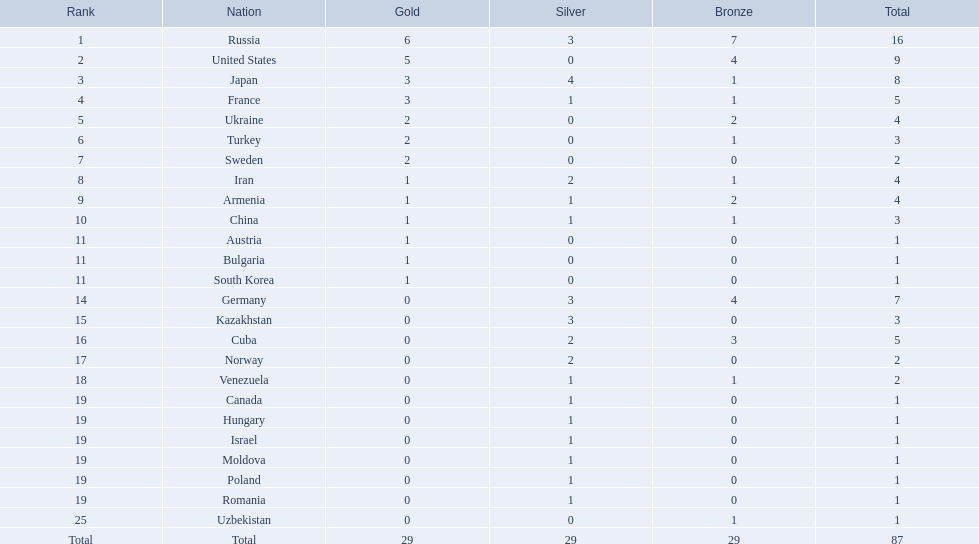What were the nations that participated in the 1995 world wrestling championships? Russia, United States, Japan, France, Ukraine, Turkey, Sweden, Iran, Armenia, China, Austria, Bulgaria, South Korea, Germany, Kazakhstan, Cuba, Norway, Venezuela, Canada, Hungary, Israel, Moldova, Poland, Romania, Uzbekistan. How many gold medals did the united states earn in the championship? 5. What amount of medals earner was greater than this value? 6. What country earned these medals? Russia. In which countries can gold medals be found? Russia, United States, Japan, France, Ukraine, Turkey, Sweden, Iran, Armenia, China, Austria, Bulgaria, South Korea. Of these countries, which have only one gold medal? Iran, Armenia, China, Austria, Bulgaria, South Korea. Of these countries, which have no bronze or silver medals? Austria. 